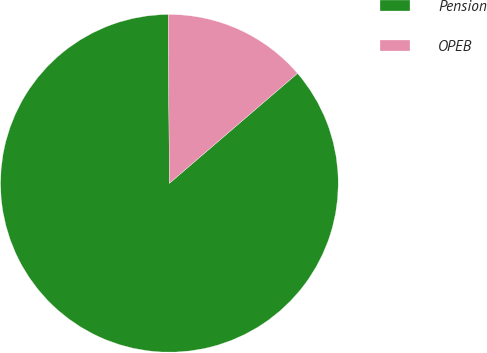<chart> <loc_0><loc_0><loc_500><loc_500><pie_chart><fcel>Pension<fcel>OPEB<nl><fcel>86.18%<fcel>13.82%<nl></chart> 